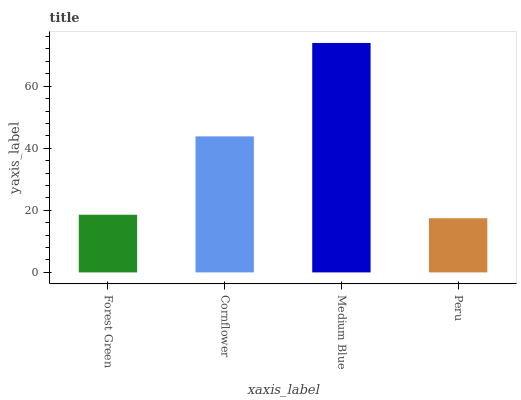Is Peru the minimum?
Answer yes or no. Yes. Is Medium Blue the maximum?
Answer yes or no. Yes. Is Cornflower the minimum?
Answer yes or no. No. Is Cornflower the maximum?
Answer yes or no. No. Is Cornflower greater than Forest Green?
Answer yes or no. Yes. Is Forest Green less than Cornflower?
Answer yes or no. Yes. Is Forest Green greater than Cornflower?
Answer yes or no. No. Is Cornflower less than Forest Green?
Answer yes or no. No. Is Cornflower the high median?
Answer yes or no. Yes. Is Forest Green the low median?
Answer yes or no. Yes. Is Forest Green the high median?
Answer yes or no. No. Is Cornflower the low median?
Answer yes or no. No. 